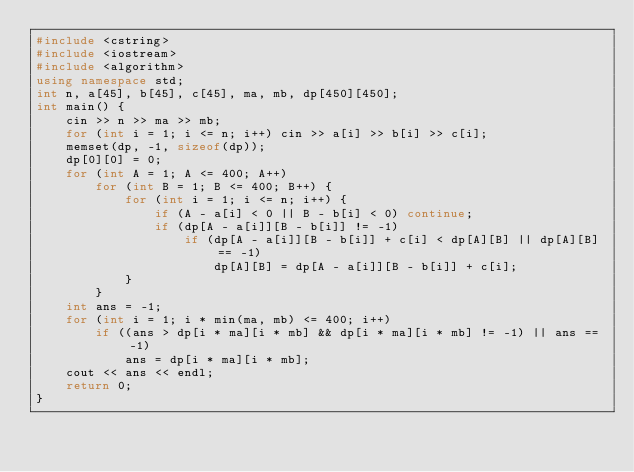<code> <loc_0><loc_0><loc_500><loc_500><_C++_>#include <cstring>
#include <iostream>
#include <algorithm>
using namespace std;
int n, a[45], b[45], c[45], ma, mb, dp[450][450];
int main() {
	cin >> n >> ma >> mb;
	for (int i = 1; i <= n; i++) cin >> a[i] >> b[i] >> c[i];
	memset(dp, -1, sizeof(dp));
	dp[0][0] = 0;
	for (int A = 1; A <= 400; A++)
		for (int B = 1; B <= 400; B++) {
			for (int i = 1; i <= n; i++) {
				if (A - a[i] < 0 || B - b[i] < 0) continue;
				if (dp[A - a[i]][B - b[i]] != -1)
					if (dp[A - a[i]][B - b[i]] + c[i] < dp[A][B] || dp[A][B] == -1)
						dp[A][B] = dp[A - a[i]][B - b[i]] + c[i];
			}
		}
	int ans = -1;
	for (int i = 1; i * min(ma, mb) <= 400; i++)
		if ((ans > dp[i * ma][i * mb] && dp[i * ma][i * mb] != -1) || ans == -1)
			ans = dp[i * ma][i * mb];
	cout << ans << endl;
	return 0;
}</code> 